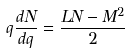Convert formula to latex. <formula><loc_0><loc_0><loc_500><loc_500>q \frac { d N } { d q } = \frac { L N - M ^ { 2 } } { 2 }</formula> 